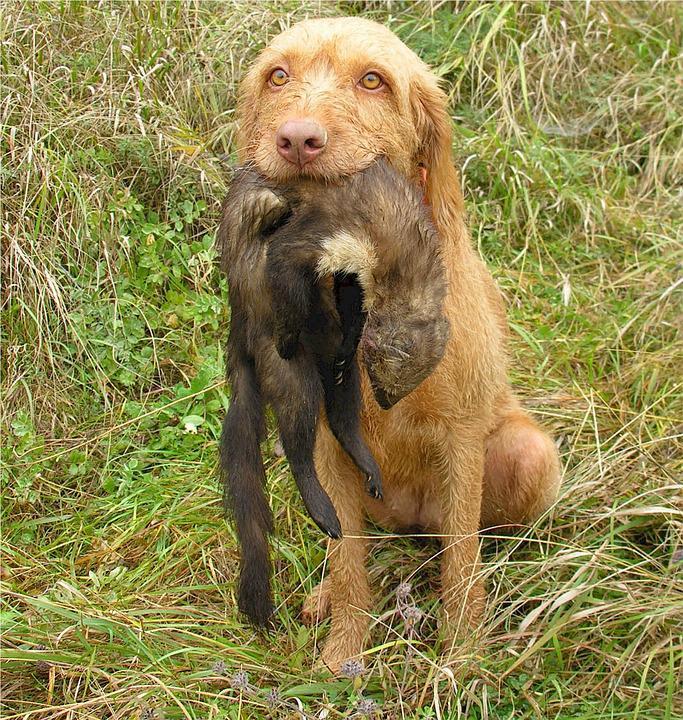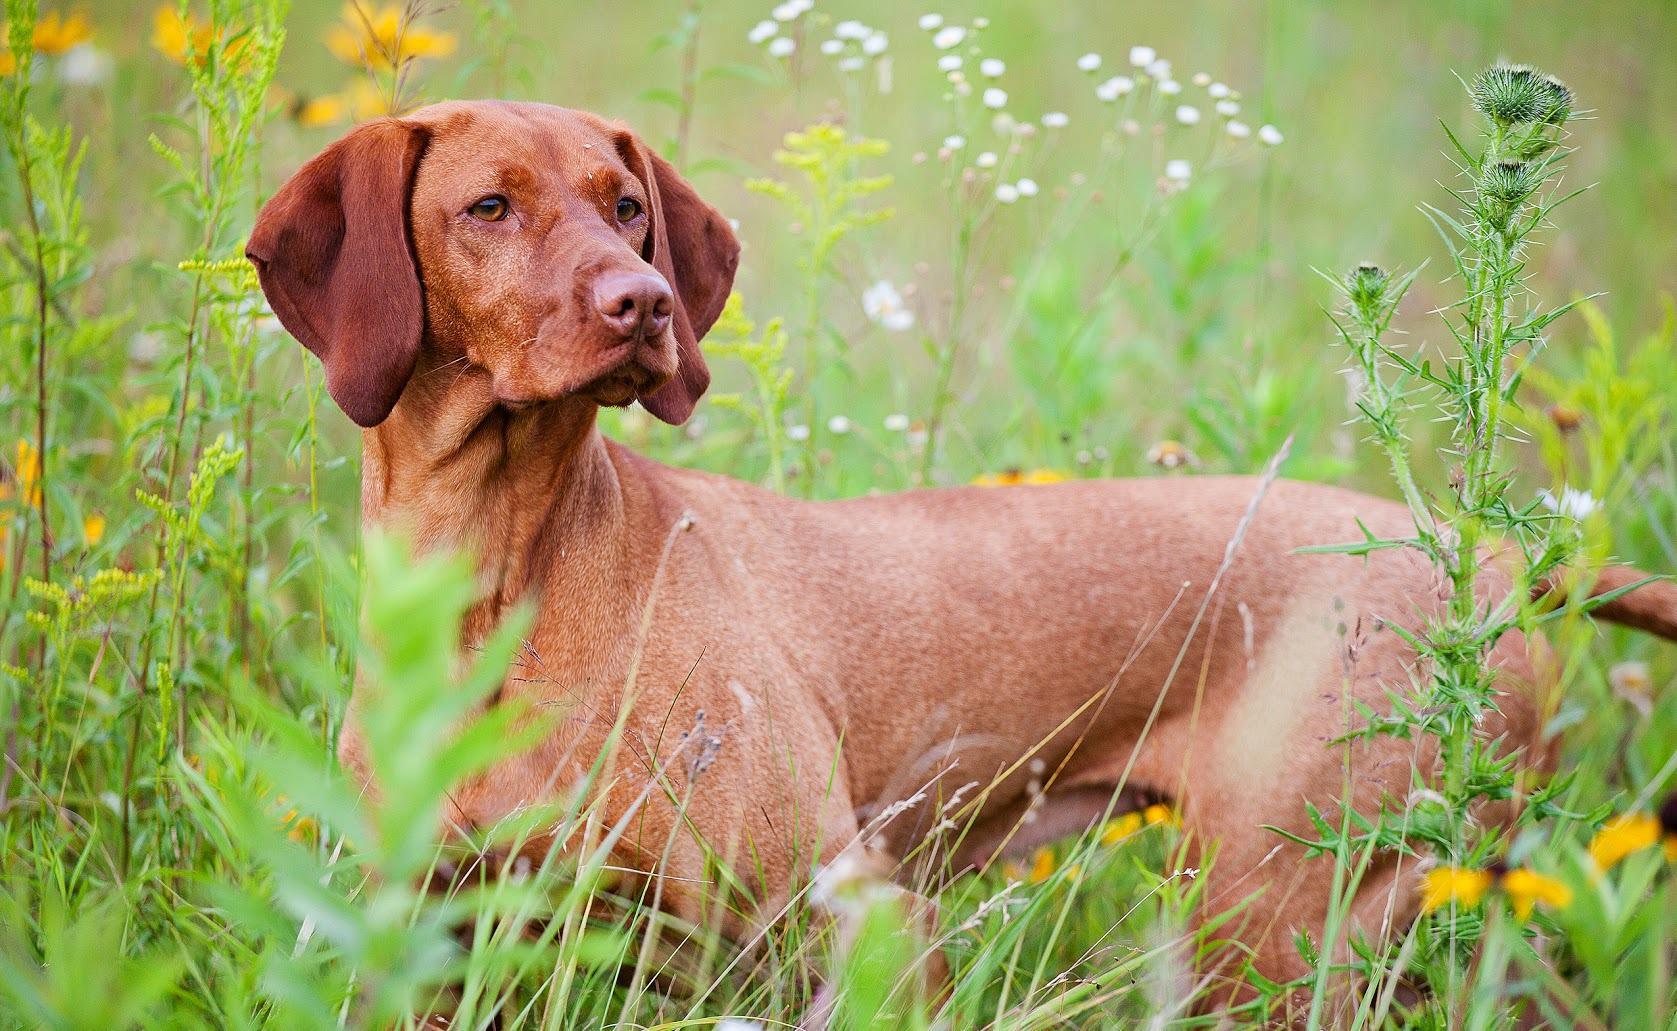The first image is the image on the left, the second image is the image on the right. Considering the images on both sides, is "There are two adult dogs" valid? Answer yes or no. Yes. The first image is the image on the left, the second image is the image on the right. Considering the images on both sides, is "At least one of the dogs is carrying something in its mouth." valid? Answer yes or no. Yes. 